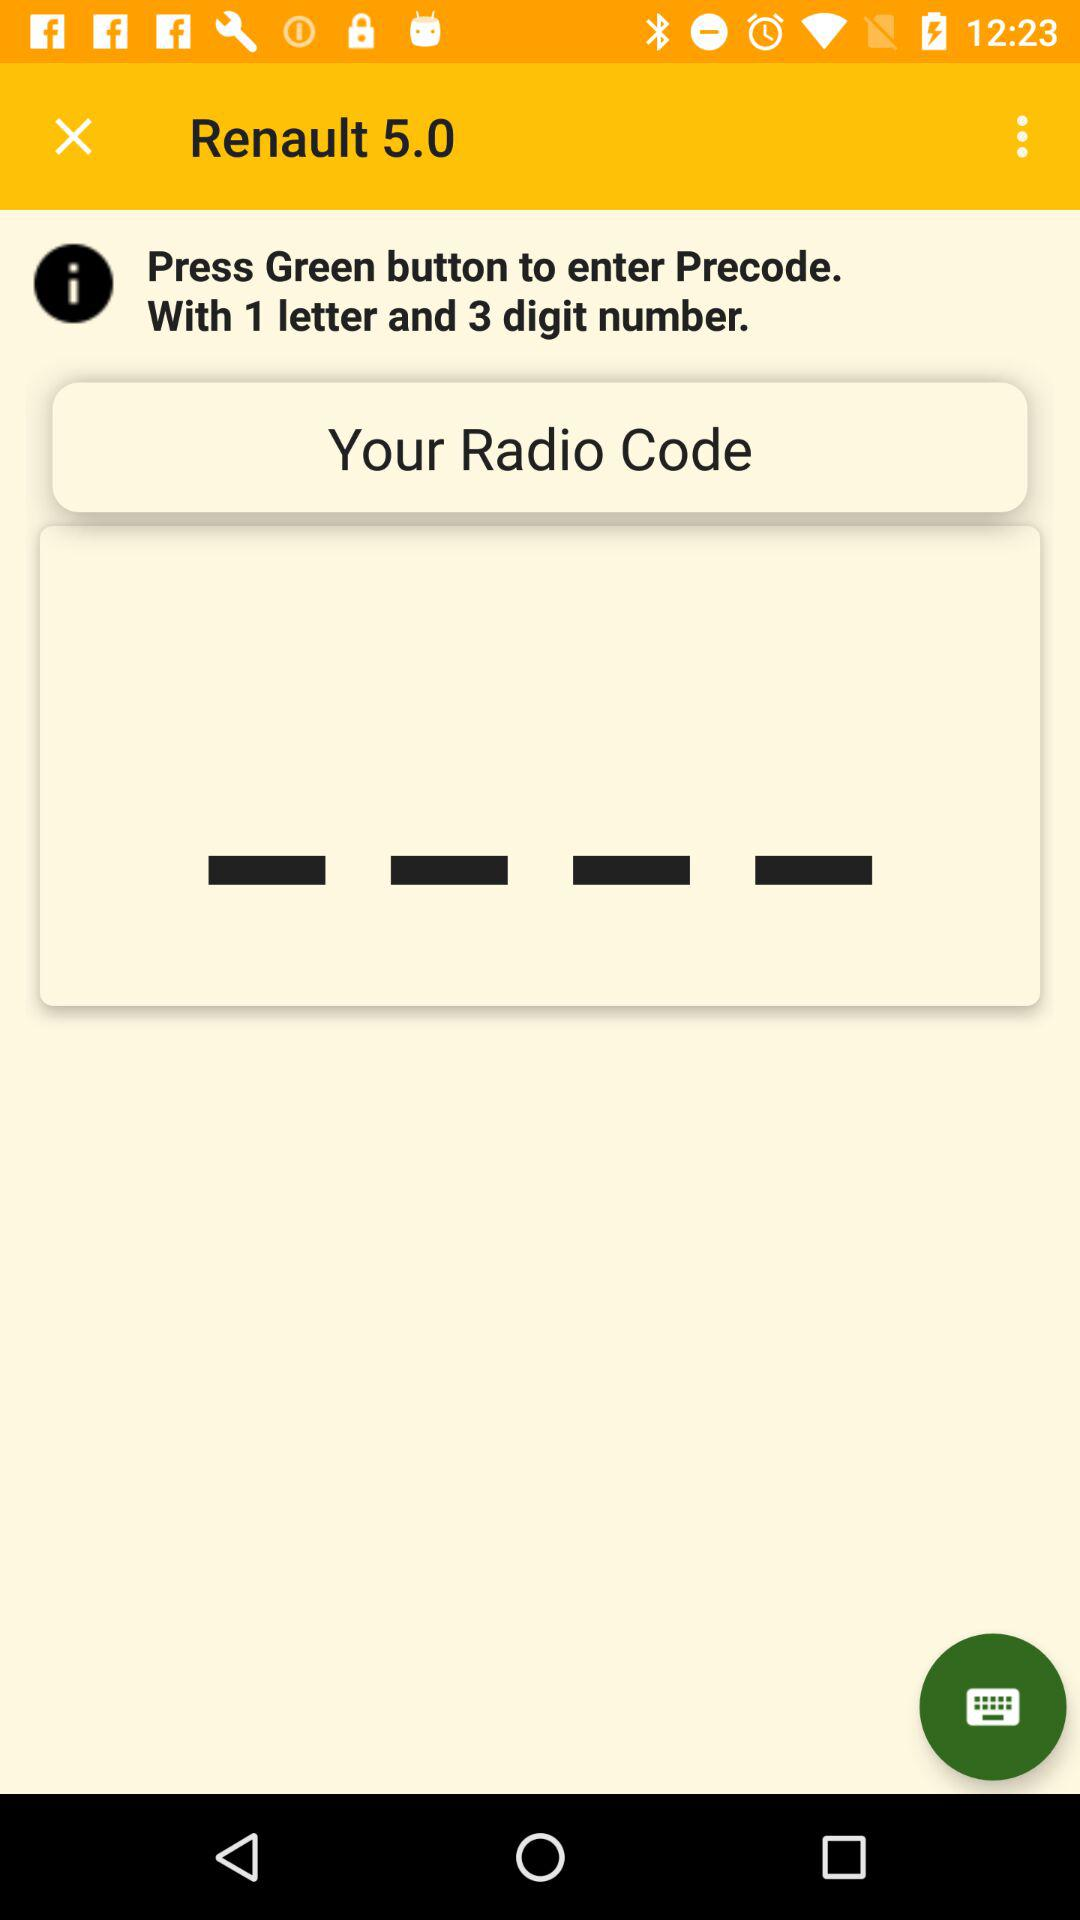What combination do we use for precode? We use the combination of "1 letter" and "3 digit number" for precode. 